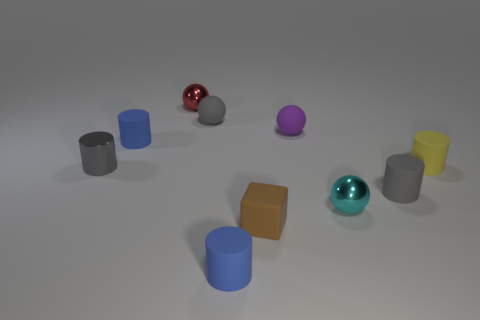How many other things are made of the same material as the tiny gray ball?
Your answer should be compact. 6. What number of tiny yellow blocks are there?
Offer a terse response. 0. How many objects are either purple spheres or things that are on the left side of the red metallic sphere?
Provide a succinct answer. 3. Is there any other thing that is the same shape as the brown thing?
Your answer should be very brief. No. There is a rubber thing that is behind the purple rubber sphere; is its size the same as the yellow object?
Provide a short and direct response. Yes. How many shiny things are small cyan spheres or gray cylinders?
Your answer should be very brief. 2. Does the purple object have the same shape as the cyan metallic object?
Offer a very short reply. Yes. What number of large objects are gray rubber things or blue objects?
Offer a terse response. 0. Are there any gray things on the right side of the small cyan metallic object?
Your answer should be compact. Yes. Are there the same number of blue matte cylinders that are behind the cyan ball and gray balls?
Offer a terse response. Yes. 